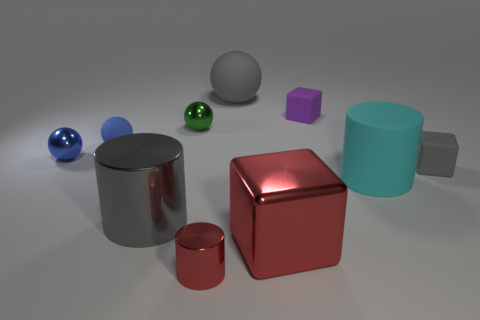There is a tiny object that is the same color as the large matte ball; what material is it?
Your answer should be very brief. Rubber. How many other objects are there of the same material as the small cylinder?
Give a very brief answer. 4. Is the color of the tiny rubber block that is in front of the tiny blue metal object the same as the large matte ball?
Your response must be concise. Yes. There is a rubber ball in front of the green object; is there a tiny purple object that is behind it?
Offer a very short reply. Yes. The gray object that is in front of the blue rubber thing and on the left side of the purple rubber thing is made of what material?
Ensure brevity in your answer.  Metal. There is a gray thing that is made of the same material as the red cylinder; what shape is it?
Ensure brevity in your answer.  Cylinder. Do the small cube to the right of the purple matte thing and the big gray ball have the same material?
Offer a terse response. Yes. There is a sphere that is to the right of the red metal cylinder; what is it made of?
Ensure brevity in your answer.  Rubber. What is the size of the rubber ball that is in front of the big matte thing that is left of the metallic cube?
Make the answer very short. Small. How many purple blocks have the same size as the cyan matte object?
Make the answer very short. 0. 